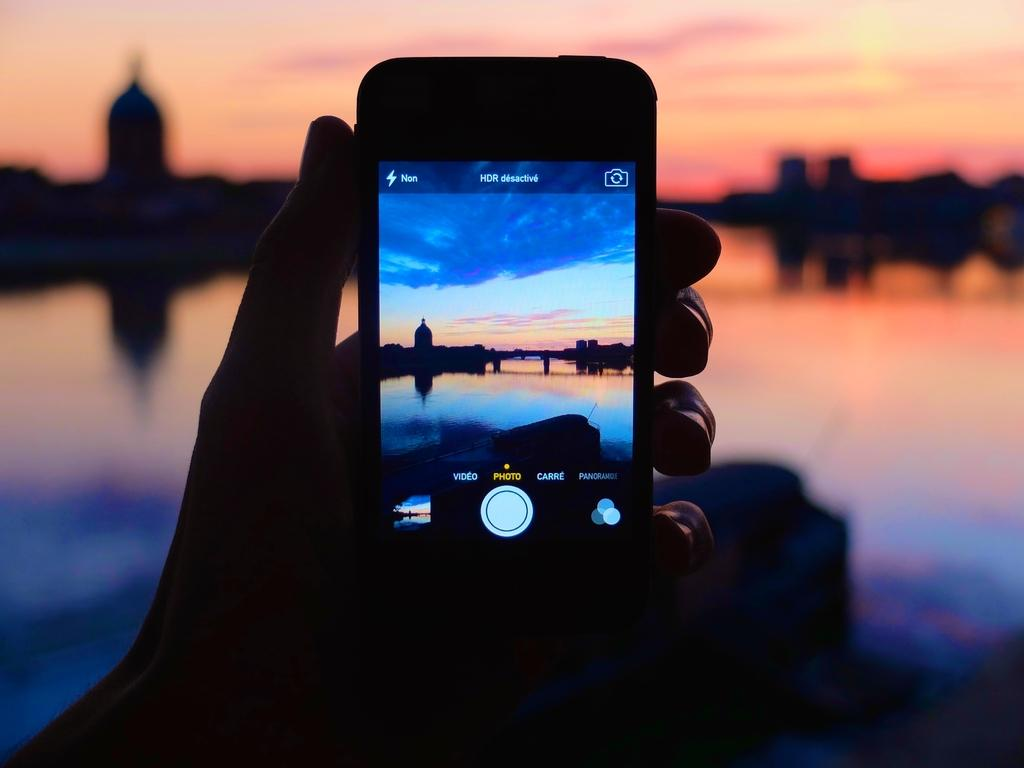<image>
Summarize the visual content of the image. Person holding a cell phone taking a picture with the word "Photo" on top of a circle button. 